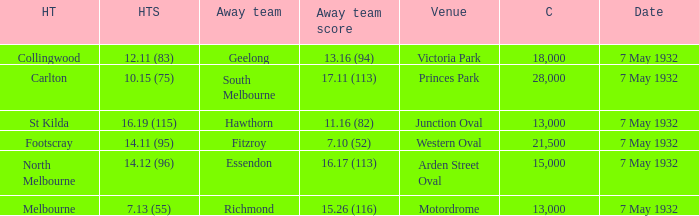What is the visiting team with an audience exceeding 13,000, and a home team score of 1 Geelong. 